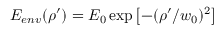<formula> <loc_0><loc_0><loc_500><loc_500>E _ { e n v } ( \rho ^ { \prime } ) = E _ { 0 } \exp { \left [ - ( \rho ^ { \prime } / { w _ { 0 } } ) ^ { 2 } \right ] }</formula> 